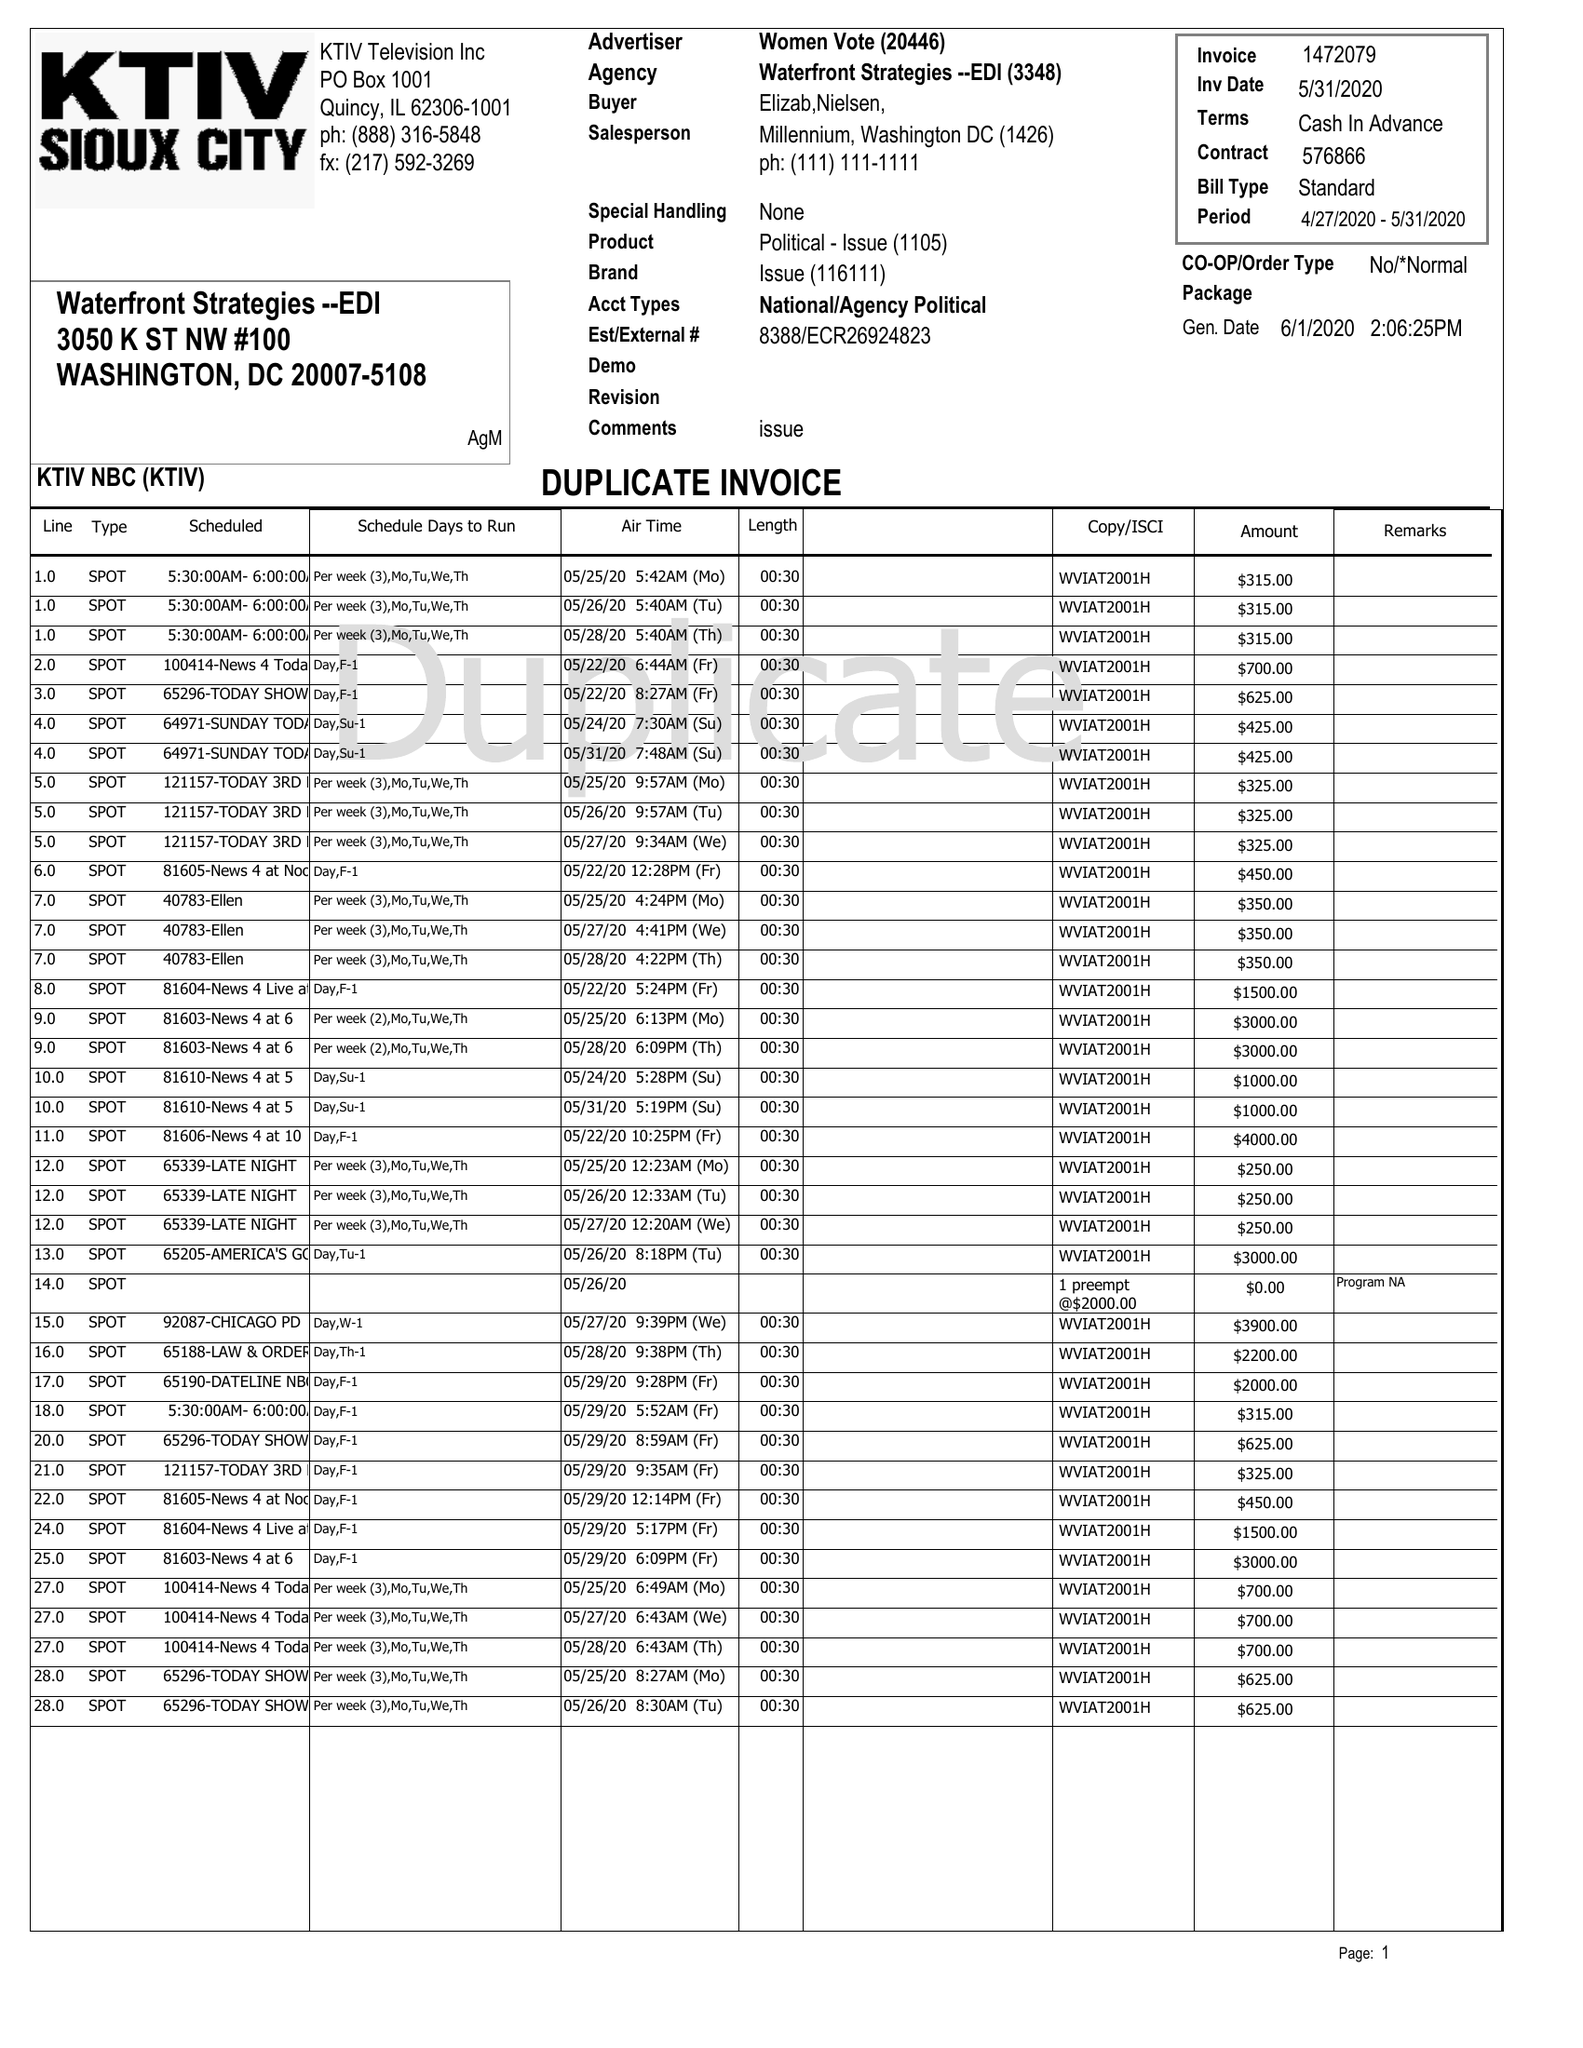What is the value for the flight_to?
Answer the question using a single word or phrase. 05/31/20 